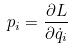<formula> <loc_0><loc_0><loc_500><loc_500>p _ { i } = \frac { \partial L } { \partial \dot { q } _ { i } }</formula> 